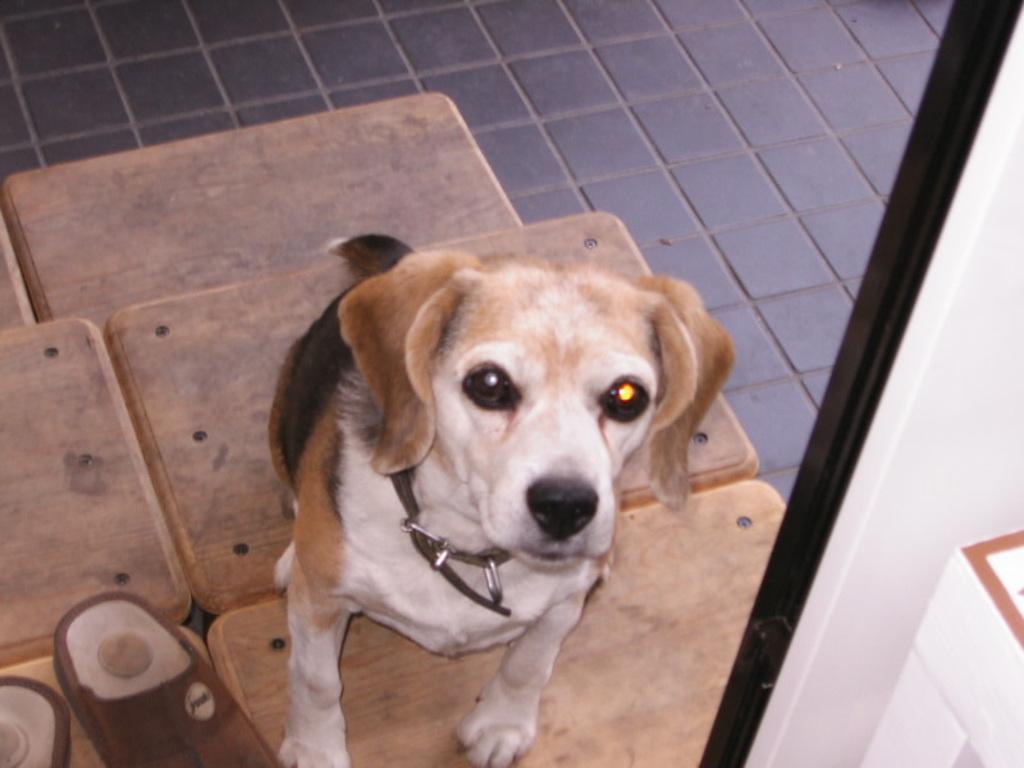Can you describe this image briefly? In this picture, we see a dog with brown, black and white color is sitting on the wooden bench. Beside the dog, there are shoes which are in brown color. On the right bottom of the picture, we see a white wall and this picture is clicked inside the room. 